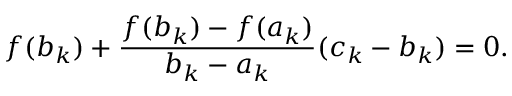<formula> <loc_0><loc_0><loc_500><loc_500>f ( b _ { k } ) + { \frac { f ( b _ { k } ) - f ( a _ { k } ) } { b _ { k } - a _ { k } } } ( c _ { k } - b _ { k } ) = 0 .</formula> 